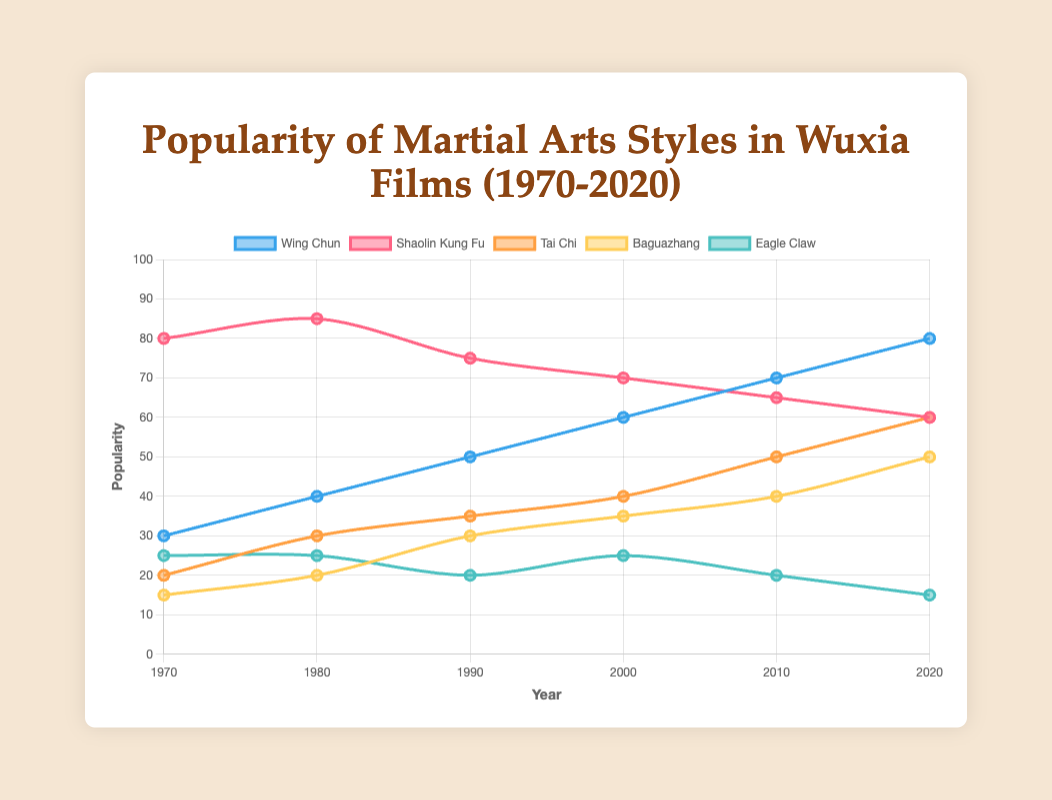What year did Wing Chun's popularity surpass Shaolin Kung Fu's popularity? From the chart, Shaolin Kung Fu was more popular than Wing Chun consistently until the year 2020, when Wing Chun's popularity reached 80 and surpassed Shaolin Kung Fu's popularity at 60.
Answer: 2020 What is the overall trend in the popularity of Tai Chi from 1970 to 2020? Observing the chart, the popularity of Tai Chi shows a rising trend from 20 in 1970 to 60 in 2020. The increase is consistent over the decades.
Answer: Rising Which martial art style had the highest peak popularity, and in which year? Shaolin Kung Fu had the highest peak popularity in 1980 with a value of 85, based on the data curves in the chart.
Answer: Shaolin Kung Fu in 1980 By how much did the popularity of Baguazhang increase from 1970 to 2020? The chart shows that in 1970, Baguazhang's popularity was 15, and in 2020 it was 50. The increase is 50 - 15 = 35.
Answer: 35 Which martial art style showed a decline in popularity from 1970 to 2020? Observing the chart, Eagle Claw started with a popularity of 25 in 1970 and dropped to 15 by 2020, indicating a decline.
Answer: Eagle Claw On average, by how much did Wing Chun's popularity increase per decade from 1970 to 2020? Wing Chun's popularity in 1970 was 30 and in 2020 it was 80. The total increase is 80 - 30 = 50 over 5 decades. The average increase per decade is 50 / 5 = 10.
Answer: 10 Which two martial arts styles had equal popularity in any given year, and what was that year? In 1980, both Eagle Claw and Wing Chun had equal popularity, each recorded at 25.
Answer: Eagle Claw and Wing Chun in 1980 How did the popularity of Shaolin Kung Fu change from 1970 to 2020? The popularity of Shaolin Kung Fu started at 80 in 1970, peaked at 85 in 1980, and gradually declined to 60 by 2020, showing a decreasing trend overall after its peak.
Answer: Declined How many martial arts styles had an increase in popularity from 2010 to 2020? Wing Chun (70 to 80), Tai Chi (50 to 60), and Baguazhang (40 to 50) showed an increase in popularity from 2010 to 2020, totaling three styles.
Answer: 3 